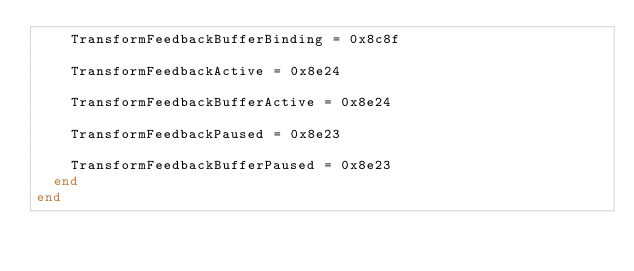<code> <loc_0><loc_0><loc_500><loc_500><_Crystal_>    TransformFeedbackBufferBinding = 0x8c8f

    TransformFeedbackActive = 0x8e24

    TransformFeedbackBufferActive = 0x8e24

    TransformFeedbackPaused = 0x8e23

    TransformFeedbackBufferPaused = 0x8e23
  end
end
</code> 